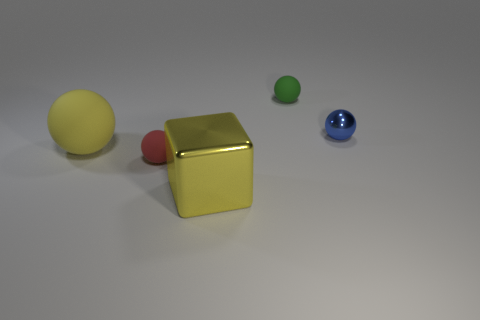There is a yellow object that is the same shape as the blue object; what is its size?
Your answer should be very brief. Large. Does the large ball on the left side of the tiny blue metal sphere have the same color as the metallic object left of the small green matte sphere?
Ensure brevity in your answer.  Yes. What number of other things are there of the same material as the small blue object
Offer a very short reply. 1. There is a yellow thing behind the large metal thing; does it have the same shape as the small thing that is behind the blue object?
Make the answer very short. Yes. Do the small red thing and the large ball have the same material?
Keep it short and to the point. Yes. What is the size of the rubber object that is behind the blue shiny ball behind the shiny thing on the left side of the blue ball?
Give a very brief answer. Small. What number of other things are there of the same color as the block?
Make the answer very short. 1. There is a green object that is the same size as the blue object; what is its shape?
Your answer should be very brief. Sphere. How many large things are green matte objects or yellow objects?
Your answer should be compact. 2. There is a tiny rubber ball in front of the sphere that is behind the shiny ball; is there a large ball to the left of it?
Give a very brief answer. Yes. 